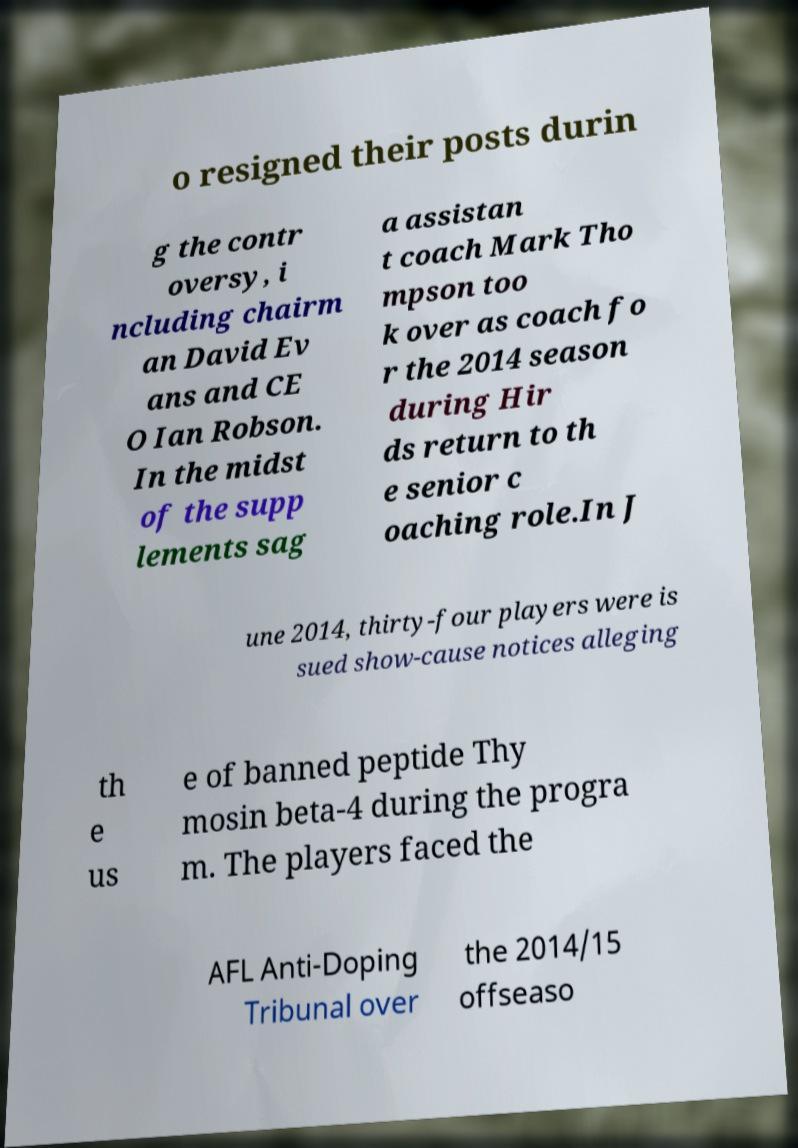I need the written content from this picture converted into text. Can you do that? o resigned their posts durin g the contr oversy, i ncluding chairm an David Ev ans and CE O Ian Robson. In the midst of the supp lements sag a assistan t coach Mark Tho mpson too k over as coach fo r the 2014 season during Hir ds return to th e senior c oaching role.In J une 2014, thirty-four players were is sued show-cause notices alleging th e us e of banned peptide Thy mosin beta-4 during the progra m. The players faced the AFL Anti-Doping Tribunal over the 2014/15 offseaso 